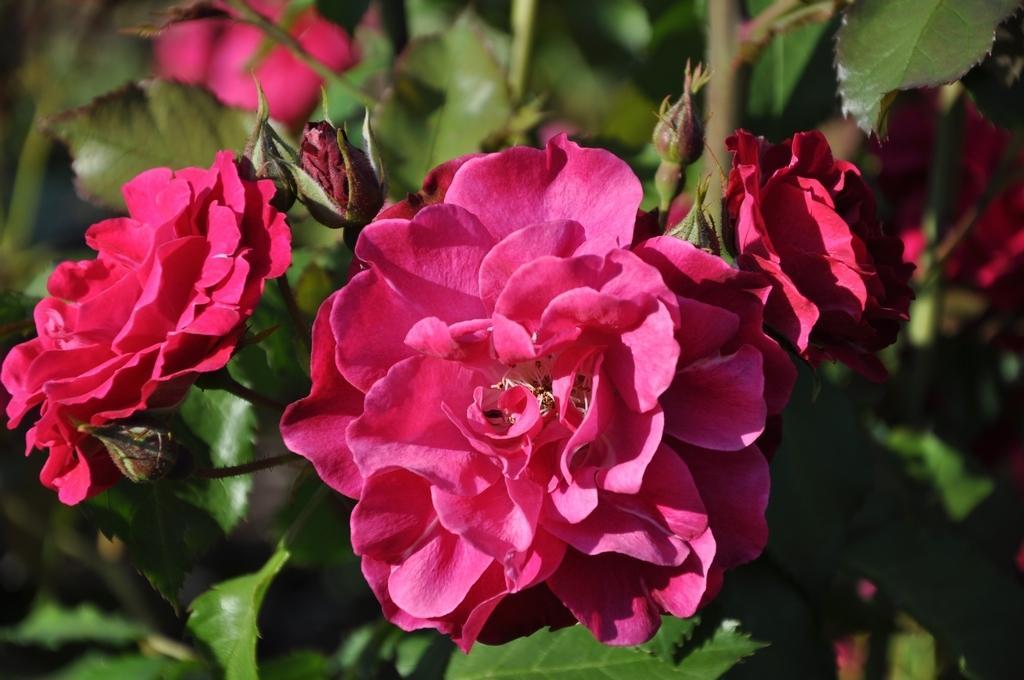In one or two sentences, can you explain what this image depicts? In this image in the front there are flowers and there are leaves. 